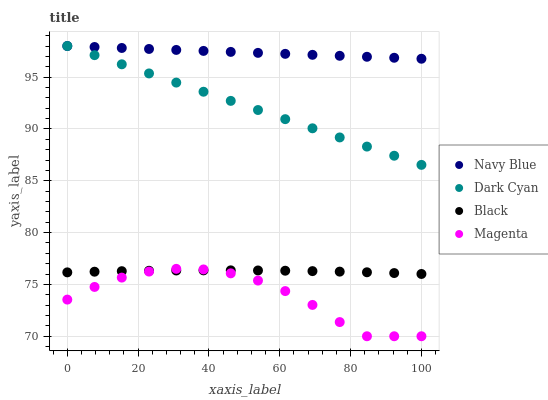Does Magenta have the minimum area under the curve?
Answer yes or no. Yes. Does Navy Blue have the maximum area under the curve?
Answer yes or no. Yes. Does Navy Blue have the minimum area under the curve?
Answer yes or no. No. Does Magenta have the maximum area under the curve?
Answer yes or no. No. Is Navy Blue the smoothest?
Answer yes or no. Yes. Is Magenta the roughest?
Answer yes or no. Yes. Is Magenta the smoothest?
Answer yes or no. No. Is Navy Blue the roughest?
Answer yes or no. No. Does Magenta have the lowest value?
Answer yes or no. Yes. Does Navy Blue have the lowest value?
Answer yes or no. No. Does Navy Blue have the highest value?
Answer yes or no. Yes. Does Magenta have the highest value?
Answer yes or no. No. Is Black less than Dark Cyan?
Answer yes or no. Yes. Is Dark Cyan greater than Black?
Answer yes or no. Yes. Does Magenta intersect Black?
Answer yes or no. Yes. Is Magenta less than Black?
Answer yes or no. No. Is Magenta greater than Black?
Answer yes or no. No. Does Black intersect Dark Cyan?
Answer yes or no. No. 